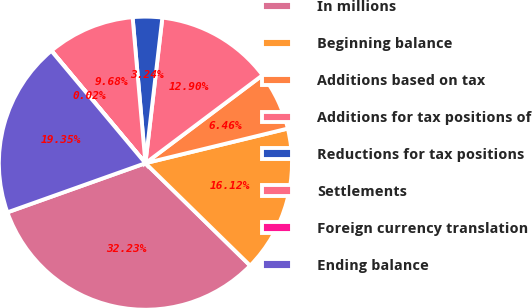<chart> <loc_0><loc_0><loc_500><loc_500><pie_chart><fcel>In millions<fcel>Beginning balance<fcel>Additions based on tax<fcel>Additions for tax positions of<fcel>Reductions for tax positions<fcel>Settlements<fcel>Foreign currency translation<fcel>Ending balance<nl><fcel>32.23%<fcel>16.12%<fcel>6.46%<fcel>12.9%<fcel>3.24%<fcel>9.68%<fcel>0.02%<fcel>19.35%<nl></chart> 